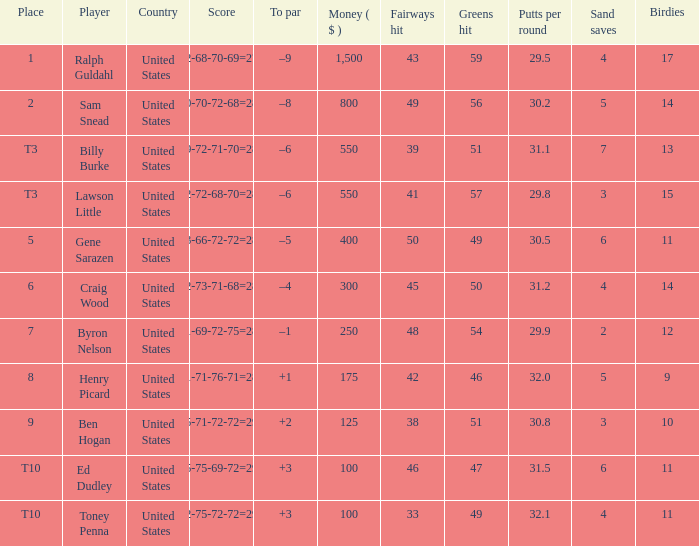Which score has a prize of $400? 73-66-72-72=283. 